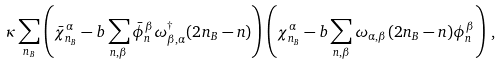Convert formula to latex. <formula><loc_0><loc_0><loc_500><loc_500>\kappa \sum _ { n _ { B } } \left ( \bar { \chi } ^ { \alpha } _ { n _ { B } } - b \sum _ { n , \beta } \bar { \phi } ^ { \beta } _ { n } \omega ^ { \dagger } _ { \beta , \alpha } ( 2 n _ { B } - n ) \right ) \left ( \chi ^ { \alpha } _ { n _ { B } } - b \sum _ { n , \beta } \omega _ { \alpha , \beta } ( 2 n _ { B } - n ) \phi ^ { \beta } _ { n } \right ) \, ,</formula> 